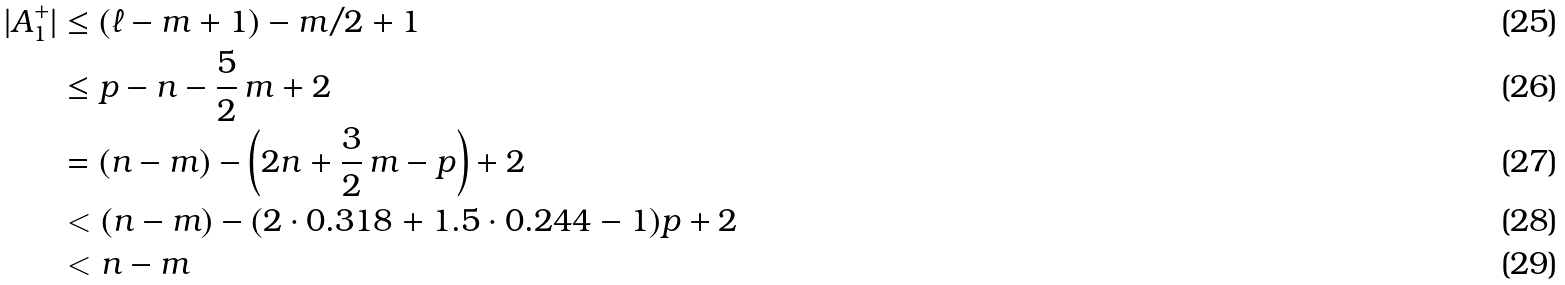<formula> <loc_0><loc_0><loc_500><loc_500>| A _ { 1 } ^ { + } | & \leq ( \ell - m + 1 ) - m / 2 + 1 \\ & \leq p - n - \frac { 5 } { 2 } \, m + 2 \\ & = ( n - m ) - \left ( 2 n + \frac { 3 } { 2 } \, m - p \right ) + 2 \\ & < ( n - m ) - ( 2 \cdot 0 . 3 1 8 + 1 . 5 \cdot 0 . 2 4 4 - 1 ) p + 2 \\ & < n - m</formula> 